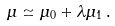Convert formula to latex. <formula><loc_0><loc_0><loc_500><loc_500>\mu \simeq \mu _ { 0 } + \lambda \mu _ { 1 } \, .</formula> 